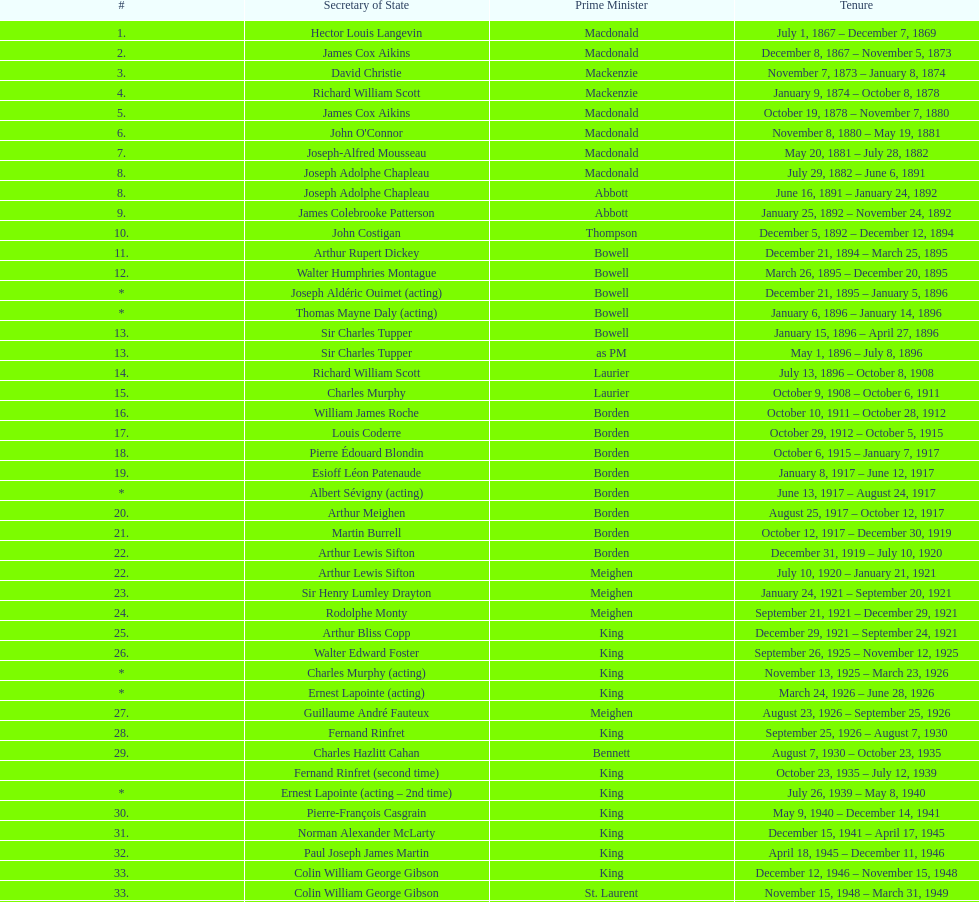Who served as thompson's secretary of state? John Costigan. Can you give me this table as a dict? {'header': ['#', 'Secretary of State', 'Prime Minister', 'Tenure'], 'rows': [['1.', 'Hector Louis Langevin', 'Macdonald', 'July 1, 1867 – December 7, 1869'], ['2.', 'James Cox Aikins', 'Macdonald', 'December 8, 1867 – November 5, 1873'], ['3.', 'David Christie', 'Mackenzie', 'November 7, 1873 – January 8, 1874'], ['4.', 'Richard William Scott', 'Mackenzie', 'January 9, 1874 – October 8, 1878'], ['5.', 'James Cox Aikins', 'Macdonald', 'October 19, 1878 – November 7, 1880'], ['6.', "John O'Connor", 'Macdonald', 'November 8, 1880 – May 19, 1881'], ['7.', 'Joseph-Alfred Mousseau', 'Macdonald', 'May 20, 1881 – July 28, 1882'], ['8.', 'Joseph Adolphe Chapleau', 'Macdonald', 'July 29, 1882 – June 6, 1891'], ['8.', 'Joseph Adolphe Chapleau', 'Abbott', 'June 16, 1891 – January 24, 1892'], ['9.', 'James Colebrooke Patterson', 'Abbott', 'January 25, 1892 – November 24, 1892'], ['10.', 'John Costigan', 'Thompson', 'December 5, 1892 – December 12, 1894'], ['11.', 'Arthur Rupert Dickey', 'Bowell', 'December 21, 1894 – March 25, 1895'], ['12.', 'Walter Humphries Montague', 'Bowell', 'March 26, 1895 – December 20, 1895'], ['*', 'Joseph Aldéric Ouimet (acting)', 'Bowell', 'December 21, 1895 – January 5, 1896'], ['*', 'Thomas Mayne Daly (acting)', 'Bowell', 'January 6, 1896 – January 14, 1896'], ['13.', 'Sir Charles Tupper', 'Bowell', 'January 15, 1896 – April 27, 1896'], ['13.', 'Sir Charles Tupper', 'as PM', 'May 1, 1896 – July 8, 1896'], ['14.', 'Richard William Scott', 'Laurier', 'July 13, 1896 – October 8, 1908'], ['15.', 'Charles Murphy', 'Laurier', 'October 9, 1908 – October 6, 1911'], ['16.', 'William James Roche', 'Borden', 'October 10, 1911 – October 28, 1912'], ['17.', 'Louis Coderre', 'Borden', 'October 29, 1912 – October 5, 1915'], ['18.', 'Pierre Édouard Blondin', 'Borden', 'October 6, 1915 – January 7, 1917'], ['19.', 'Esioff Léon Patenaude', 'Borden', 'January 8, 1917 – June 12, 1917'], ['*', 'Albert Sévigny (acting)', 'Borden', 'June 13, 1917 – August 24, 1917'], ['20.', 'Arthur Meighen', 'Borden', 'August 25, 1917 – October 12, 1917'], ['21.', 'Martin Burrell', 'Borden', 'October 12, 1917 – December 30, 1919'], ['22.', 'Arthur Lewis Sifton', 'Borden', 'December 31, 1919 – July 10, 1920'], ['22.', 'Arthur Lewis Sifton', 'Meighen', 'July 10, 1920 – January 21, 1921'], ['23.', 'Sir Henry Lumley Drayton', 'Meighen', 'January 24, 1921 – September 20, 1921'], ['24.', 'Rodolphe Monty', 'Meighen', 'September 21, 1921 – December 29, 1921'], ['25.', 'Arthur Bliss Copp', 'King', 'December 29, 1921 – September 24, 1921'], ['26.', 'Walter Edward Foster', 'King', 'September 26, 1925 – November 12, 1925'], ['*', 'Charles Murphy (acting)', 'King', 'November 13, 1925 – March 23, 1926'], ['*', 'Ernest Lapointe (acting)', 'King', 'March 24, 1926 – June 28, 1926'], ['27.', 'Guillaume André Fauteux', 'Meighen', 'August 23, 1926 – September 25, 1926'], ['28.', 'Fernand Rinfret', 'King', 'September 25, 1926 – August 7, 1930'], ['29.', 'Charles Hazlitt Cahan', 'Bennett', 'August 7, 1930 – October 23, 1935'], ['', 'Fernand Rinfret (second time)', 'King', 'October 23, 1935 – July 12, 1939'], ['*', 'Ernest Lapointe (acting – 2nd time)', 'King', 'July 26, 1939 – May 8, 1940'], ['30.', 'Pierre-François Casgrain', 'King', 'May 9, 1940 – December 14, 1941'], ['31.', 'Norman Alexander McLarty', 'King', 'December 15, 1941 – April 17, 1945'], ['32.', 'Paul Joseph James Martin', 'King', 'April 18, 1945 – December 11, 1946'], ['33.', 'Colin William George Gibson', 'King', 'December 12, 1946 – November 15, 1948'], ['33.', 'Colin William George Gibson', 'St. Laurent', 'November 15, 1948 – March 31, 1949'], ['34.', 'Frederick Gordon Bradley', 'St. Laurent', 'March 31, 1949 – June 11, 1953'], ['35.', 'Jack Pickersgill', 'St. Laurent', 'June 11, 1953 – June 30, 1954'], ['36.', 'Roch Pinard', 'St. Laurent', 'July 1, 1954 – June 21, 1957'], ['37.', 'Ellen Louks Fairclough', 'Diefenbaker', 'June 21, 1957 – May 11, 1958'], ['38.', 'Henri Courtemanche', 'Diefenbaker', 'May 12, 1958 – June 19, 1960'], ['*', 'Léon Balcer (acting minister)', 'Diefenbaker', 'June 21, 1960 – October 10, 1960'], ['39.', 'Noël Dorion', 'Diefenbaker', 'October 11, 1960 – July 5, 1962'], ['*', 'Léon Balcer (acting minister – 2nd time)', 'Diefenbaker', 'July 11, 1962 – August 8, 1962'], ['40.', 'George Ernest Halpenny', 'Diefenbaker', 'August 9, 1962 – April 22, 1963'], ['', 'Jack Pickersgill (second time)', 'Pearson', 'April 22, 1963 – February 2, 1964'], ['41.', 'Maurice Lamontagne', 'Pearson', 'February 2, 1964 – December 17, 1965'], ['42.', 'Judy LaMarsh', 'Pearson', 'December 17, 1965 – April 9, 1968'], ['*', 'John Joseph Connolly (acting minister)', 'Pearson', 'April 10, 1968 – April 20, 1968'], ['43.', 'Jean Marchand', 'Trudeau', 'April 20, 1968 – July 5, 1968'], ['44.', 'Gérard Pelletier', 'Trudeau', 'July 5, 1968 – November 26, 1972'], ['45.', 'James Hugh Faulkner', 'Trudeau', 'November 27, 1972 – September 13, 1976'], ['46.', 'John Roberts', 'Trudeau', 'September 14, 1976 – June 3, 1979'], ['47.', 'David MacDonald', 'Clark', 'June 4, 1979 – March 2, 1980'], ['48.', 'Francis Fox', 'Trudeau', 'March 3, 1980 – September 21, 1981'], ['49.', 'Gerald Regan', 'Trudeau', 'September 22, 1981 – October 5, 1982'], ['50.', 'Serge Joyal', 'Trudeau', 'October 6, 1982 – June 29, 1984'], ['50.', 'Serge Joyal', 'Turner', 'June 30, 1984 – September 16, 1984'], ['51.', 'Walter McLean', 'Mulroney', 'September 17, 1984 – April 19, 1985'], ['52.', 'Benoit Bouchard', 'Mulroney', 'April 20, 1985 – June 29, 1986'], ['53.', 'David Crombie', 'Mulroney', 'June 30, 1986 – March 30, 1988'], ['54.', 'Lucien Bouchard', 'Mulroney', 'March 31, 1988 – January 29, 1989'], ['55.', 'Gerry Weiner', 'Mulroney', 'January 30, 1989 – April 20, 1991'], ['56.', 'Robert de Cotret', 'Mulroney', 'April 21, 1991 – January 3, 1993'], ['57.', 'Monique Landry', 'Mulroney', 'January 4, 1993 – June 24, 1993'], ['57.', 'Monique Landry', 'Campbell', 'June 24, 1993 – November 3, 1993'], ['58.', 'Sergio Marchi', 'Chrétien', 'November 4, 1993 – January 24, 1996'], ['59.', 'Lucienne Robillard', 'Chrétien', 'January 25, 1996 – July 12, 1996']]} 